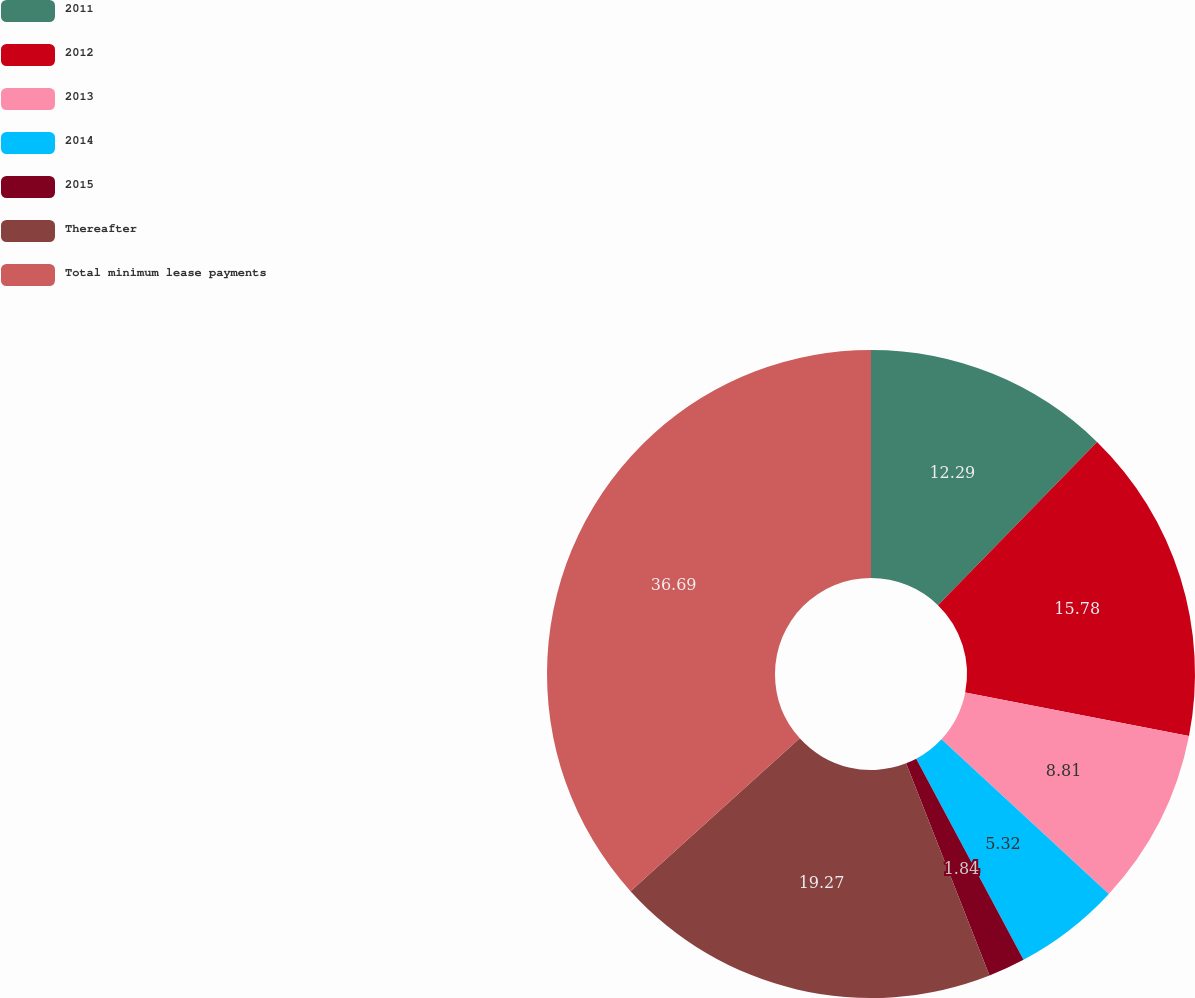Convert chart to OTSL. <chart><loc_0><loc_0><loc_500><loc_500><pie_chart><fcel>2011<fcel>2012<fcel>2013<fcel>2014<fcel>2015<fcel>Thereafter<fcel>Total minimum lease payments<nl><fcel>12.29%<fcel>15.78%<fcel>8.81%<fcel>5.32%<fcel>1.84%<fcel>19.27%<fcel>36.69%<nl></chart> 